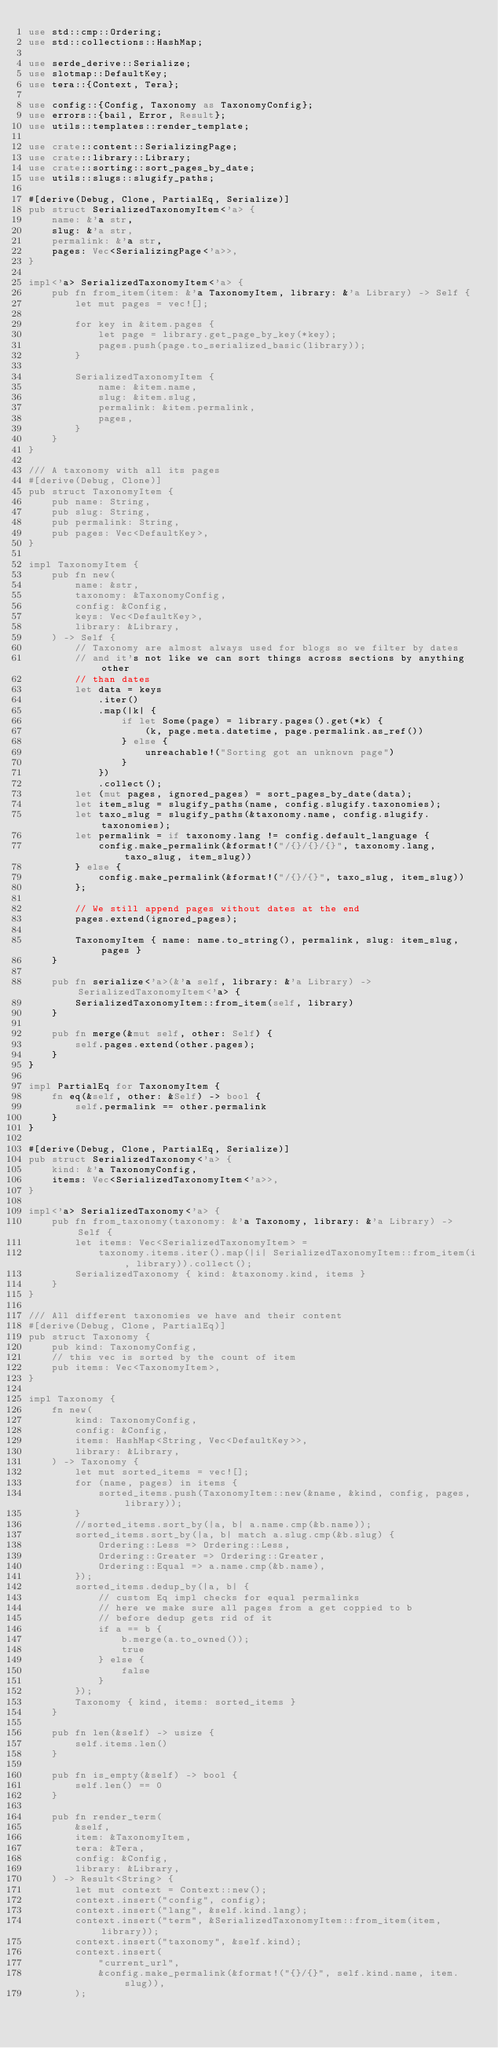Convert code to text. <code><loc_0><loc_0><loc_500><loc_500><_Rust_>use std::cmp::Ordering;
use std::collections::HashMap;

use serde_derive::Serialize;
use slotmap::DefaultKey;
use tera::{Context, Tera};

use config::{Config, Taxonomy as TaxonomyConfig};
use errors::{bail, Error, Result};
use utils::templates::render_template;

use crate::content::SerializingPage;
use crate::library::Library;
use crate::sorting::sort_pages_by_date;
use utils::slugs::slugify_paths;

#[derive(Debug, Clone, PartialEq, Serialize)]
pub struct SerializedTaxonomyItem<'a> {
    name: &'a str,
    slug: &'a str,
    permalink: &'a str,
    pages: Vec<SerializingPage<'a>>,
}

impl<'a> SerializedTaxonomyItem<'a> {
    pub fn from_item(item: &'a TaxonomyItem, library: &'a Library) -> Self {
        let mut pages = vec![];

        for key in &item.pages {
            let page = library.get_page_by_key(*key);
            pages.push(page.to_serialized_basic(library));
        }

        SerializedTaxonomyItem {
            name: &item.name,
            slug: &item.slug,
            permalink: &item.permalink,
            pages,
        }
    }
}

/// A taxonomy with all its pages
#[derive(Debug, Clone)]
pub struct TaxonomyItem {
    pub name: String,
    pub slug: String,
    pub permalink: String,
    pub pages: Vec<DefaultKey>,
}

impl TaxonomyItem {
    pub fn new(
        name: &str,
        taxonomy: &TaxonomyConfig,
        config: &Config,
        keys: Vec<DefaultKey>,
        library: &Library,
    ) -> Self {
        // Taxonomy are almost always used for blogs so we filter by dates
        // and it's not like we can sort things across sections by anything other
        // than dates
        let data = keys
            .iter()
            .map(|k| {
                if let Some(page) = library.pages().get(*k) {
                    (k, page.meta.datetime, page.permalink.as_ref())
                } else {
                    unreachable!("Sorting got an unknown page")
                }
            })
            .collect();
        let (mut pages, ignored_pages) = sort_pages_by_date(data);
        let item_slug = slugify_paths(name, config.slugify.taxonomies);
        let taxo_slug = slugify_paths(&taxonomy.name, config.slugify.taxonomies);
        let permalink = if taxonomy.lang != config.default_language {
            config.make_permalink(&format!("/{}/{}/{}", taxonomy.lang, taxo_slug, item_slug))
        } else {
            config.make_permalink(&format!("/{}/{}", taxo_slug, item_slug))
        };

        // We still append pages without dates at the end
        pages.extend(ignored_pages);

        TaxonomyItem { name: name.to_string(), permalink, slug: item_slug, pages }
    }

    pub fn serialize<'a>(&'a self, library: &'a Library) -> SerializedTaxonomyItem<'a> {
        SerializedTaxonomyItem::from_item(self, library)
    }

    pub fn merge(&mut self, other: Self) {
        self.pages.extend(other.pages);
    }
}

impl PartialEq for TaxonomyItem {
    fn eq(&self, other: &Self) -> bool {
        self.permalink == other.permalink
    }
}

#[derive(Debug, Clone, PartialEq, Serialize)]
pub struct SerializedTaxonomy<'a> {
    kind: &'a TaxonomyConfig,
    items: Vec<SerializedTaxonomyItem<'a>>,
}

impl<'a> SerializedTaxonomy<'a> {
    pub fn from_taxonomy(taxonomy: &'a Taxonomy, library: &'a Library) -> Self {
        let items: Vec<SerializedTaxonomyItem> =
            taxonomy.items.iter().map(|i| SerializedTaxonomyItem::from_item(i, library)).collect();
        SerializedTaxonomy { kind: &taxonomy.kind, items }
    }
}

/// All different taxonomies we have and their content
#[derive(Debug, Clone, PartialEq)]
pub struct Taxonomy {
    pub kind: TaxonomyConfig,
    // this vec is sorted by the count of item
    pub items: Vec<TaxonomyItem>,
}

impl Taxonomy {
    fn new(
        kind: TaxonomyConfig,
        config: &Config,
        items: HashMap<String, Vec<DefaultKey>>,
        library: &Library,
    ) -> Taxonomy {
        let mut sorted_items = vec![];
        for (name, pages) in items {
            sorted_items.push(TaxonomyItem::new(&name, &kind, config, pages, library));
        }
        //sorted_items.sort_by(|a, b| a.name.cmp(&b.name));
        sorted_items.sort_by(|a, b| match a.slug.cmp(&b.slug) {
            Ordering::Less => Ordering::Less,
            Ordering::Greater => Ordering::Greater,
            Ordering::Equal => a.name.cmp(&b.name),
        });
        sorted_items.dedup_by(|a, b| {
            // custom Eq impl checks for equal permalinks
            // here we make sure all pages from a get coppied to b
            // before dedup gets rid of it
            if a == b {
                b.merge(a.to_owned());
                true
            } else {
                false
            }
        });
        Taxonomy { kind, items: sorted_items }
    }

    pub fn len(&self) -> usize {
        self.items.len()
    }

    pub fn is_empty(&self) -> bool {
        self.len() == 0
    }

    pub fn render_term(
        &self,
        item: &TaxonomyItem,
        tera: &Tera,
        config: &Config,
        library: &Library,
    ) -> Result<String> {
        let mut context = Context::new();
        context.insert("config", config);
        context.insert("lang", &self.kind.lang);
        context.insert("term", &SerializedTaxonomyItem::from_item(item, library));
        context.insert("taxonomy", &self.kind);
        context.insert(
            "current_url",
            &config.make_permalink(&format!("{}/{}", self.kind.name, item.slug)),
        );</code> 